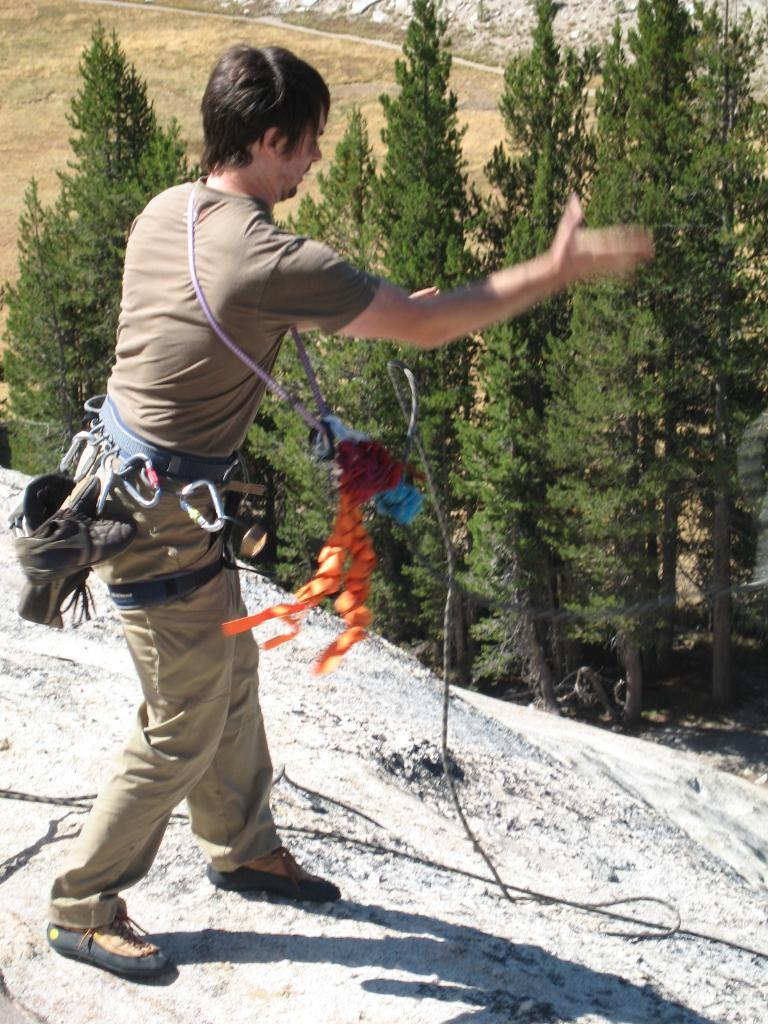What is located on the left side of the image? There is a man standing on the left side of the image. What can be seen in the middle of the image? There are trees in the middle of the image. What type of clothing is the man wearing? The man is wearing belts and shoes. What type of punishment is the man receiving in the image? There is no indication of punishment in the image; the man is simply standing on the left side. 